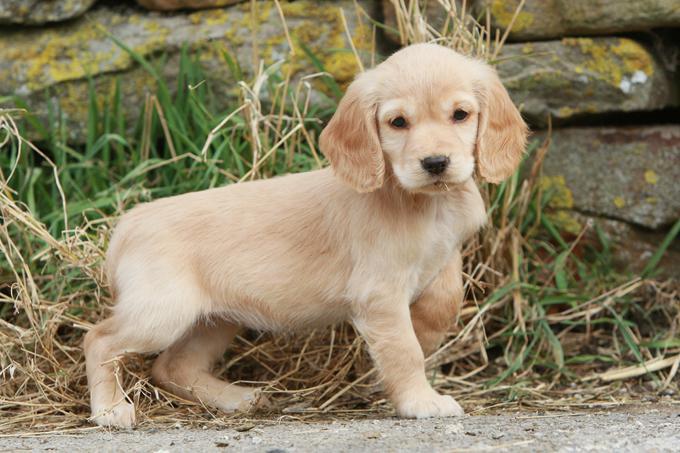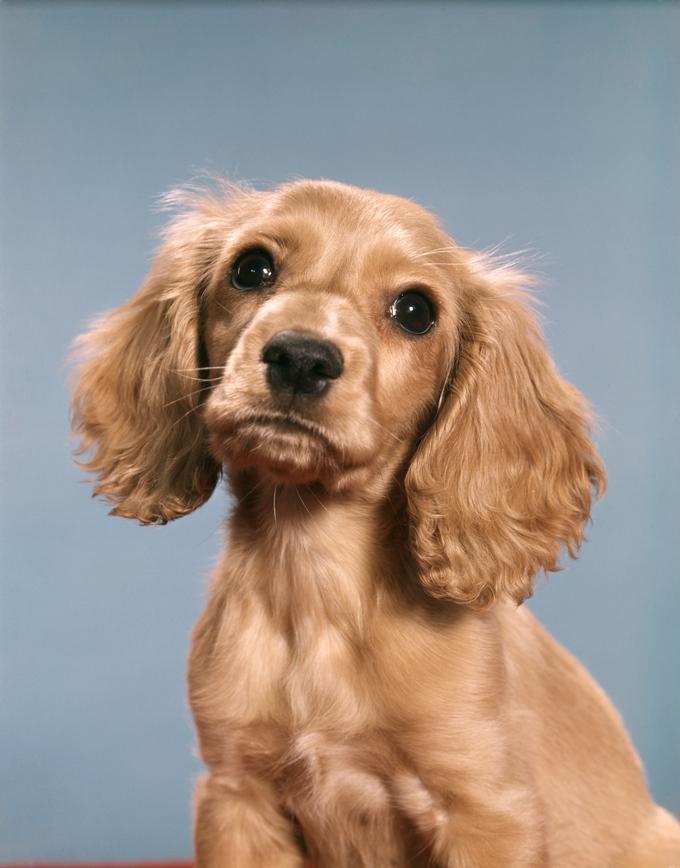The first image is the image on the left, the second image is the image on the right. Analyze the images presented: Is the assertion "The dogs on the left image have plain white background." valid? Answer yes or no. No. 